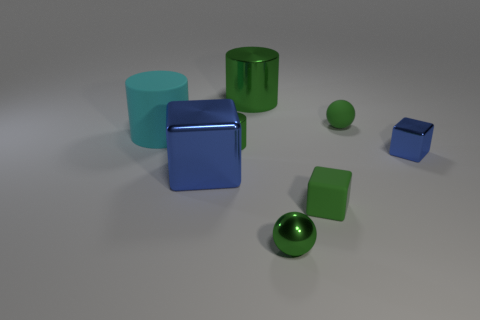What material is the tiny thing on the right side of the small green sphere behind the big cyan thing?
Your answer should be very brief. Metal. What is the green cylinder that is in front of the large green cylinder made of?
Make the answer very short. Metal. The tiny ball in front of the metal cube to the left of the tiny blue object is what color?
Provide a succinct answer. Green. Is the number of big cyan matte objects less than the number of big things?
Provide a succinct answer. Yes. What number of big cyan matte things have the same shape as the small blue shiny object?
Give a very brief answer. 0. There is a rubber thing that is the same size as the rubber sphere; what color is it?
Offer a terse response. Green. Are there an equal number of green objects right of the tiny matte block and metal spheres left of the large cyan rubber cylinder?
Your response must be concise. No. Is there a green thing that has the same size as the green block?
Ensure brevity in your answer.  Yes. What is the size of the rubber cylinder?
Give a very brief answer. Large. Are there the same number of small blocks to the right of the small green cube and tiny rubber objects?
Ensure brevity in your answer.  No. 